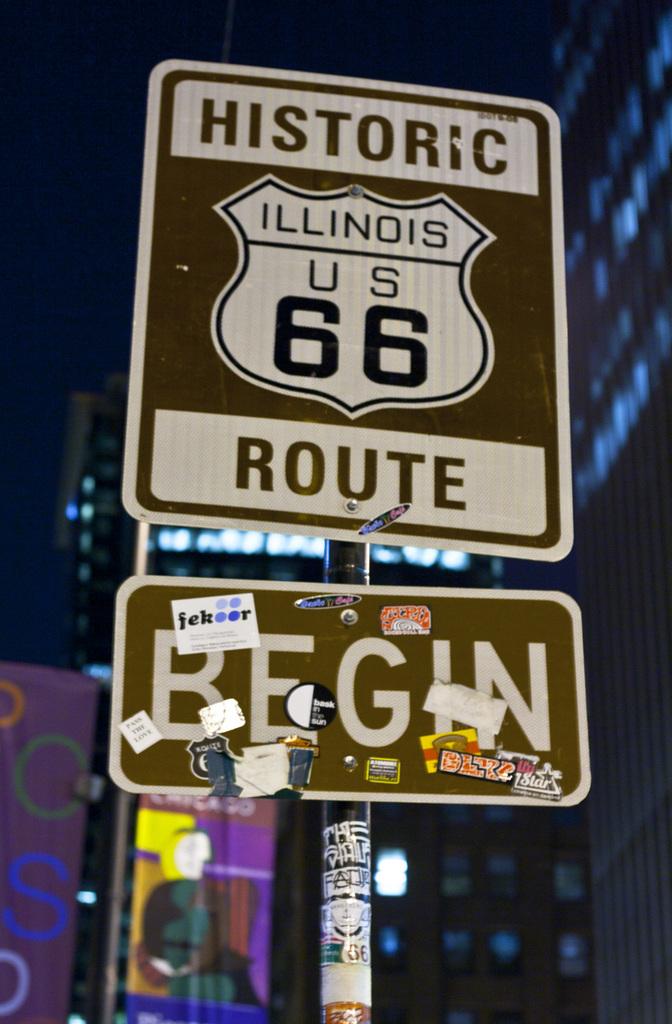What does the bottom sign say?
Keep it short and to the point. Begin. 